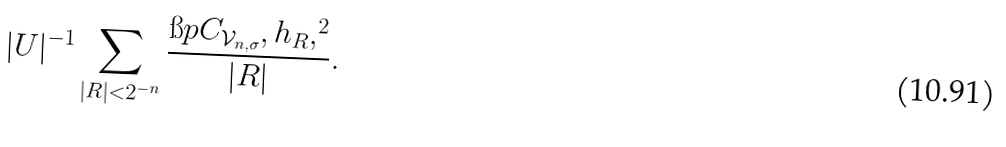Convert formula to latex. <formula><loc_0><loc_0><loc_500><loc_500>| U | ^ { - 1 } \sum _ { | R | < 2 ^ { - n } } \frac { \i p C _ { \mathcal { V } _ { n , \sigma } } , h _ { R } , ^ { 2 } } { | R | } .</formula> 